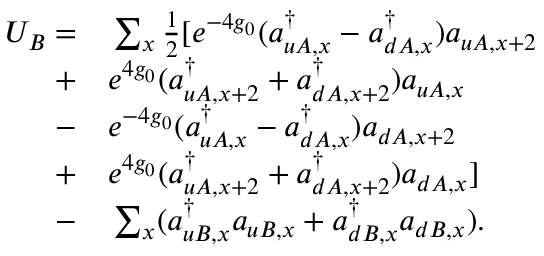<formula> <loc_0><loc_0><loc_500><loc_500>\begin{array} { r l } { U _ { B } = } & \sum _ { x } \frac { 1 } { 2 } [ e ^ { - 4 g _ { 0 } } ( a _ { u A , x } ^ { \dagger } - a _ { d A , x } ^ { \dagger } ) a _ { u A , x + 2 } } \\ { + } & e ^ { 4 g _ { 0 } } ( a _ { u A , x + 2 } ^ { \dagger } + a _ { d A , x + 2 } ^ { \dagger } ) a _ { u A , x } } \\ { - } & e ^ { - 4 g _ { 0 } } ( a _ { u A , x } ^ { \dagger } - a _ { d A , x } ^ { \dagger } ) a _ { d A , x + 2 } } \\ { + } & e ^ { 4 g _ { 0 } } ( a _ { u A , x + 2 } ^ { \dagger } + a _ { d A , x + 2 } ^ { \dagger } ) a _ { d A , x } ] } \\ { - } & \sum _ { x } ( a _ { u B , x } ^ { \dagger } a _ { u B , x } + a _ { d B , x } ^ { \dagger } a _ { d B , x } ) . } \end{array}</formula> 